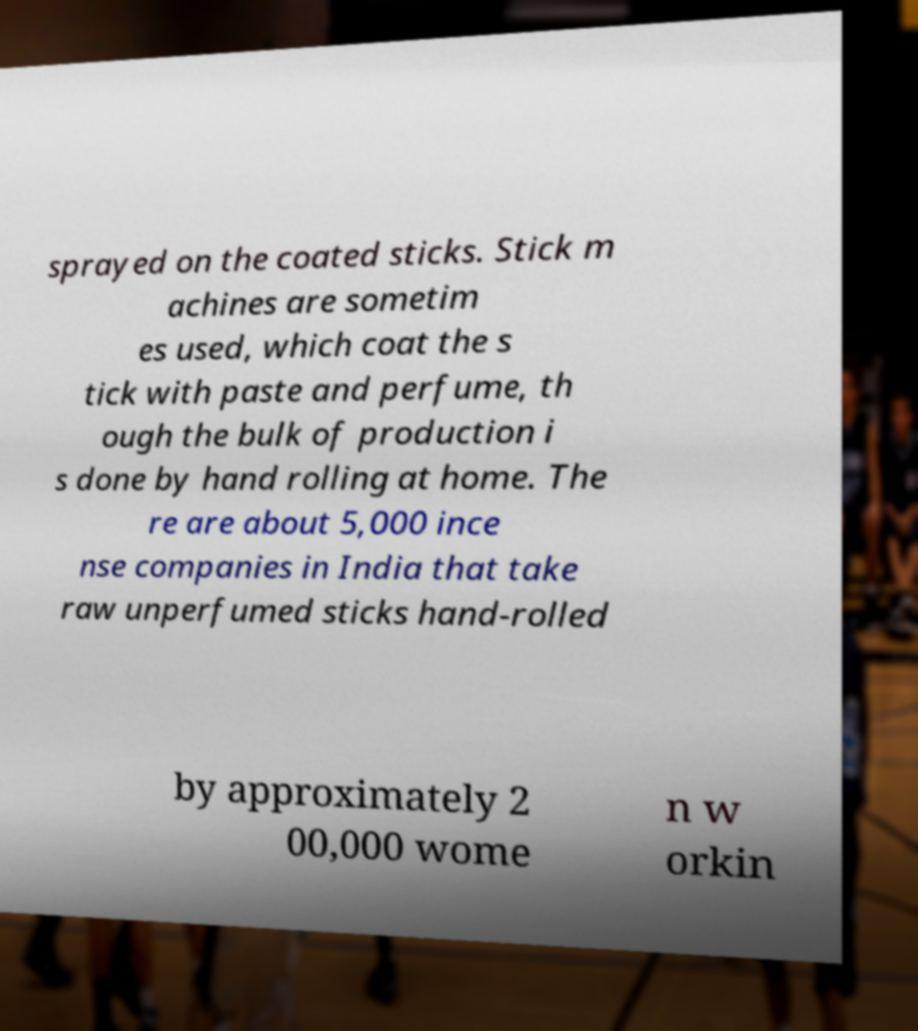There's text embedded in this image that I need extracted. Can you transcribe it verbatim? sprayed on the coated sticks. Stick m achines are sometim es used, which coat the s tick with paste and perfume, th ough the bulk of production i s done by hand rolling at home. The re are about 5,000 ince nse companies in India that take raw unperfumed sticks hand-rolled by approximately 2 00,000 wome n w orkin 